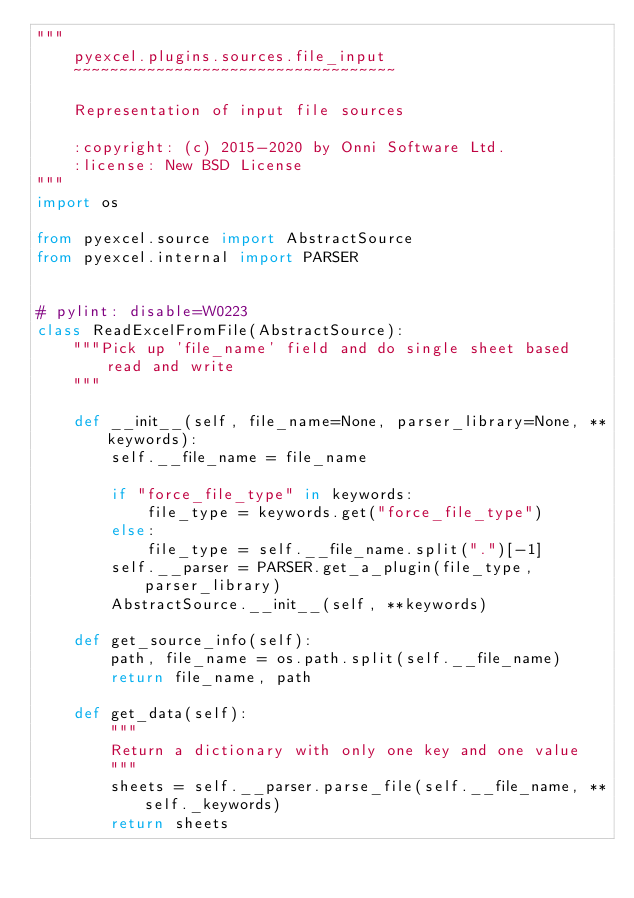Convert code to text. <code><loc_0><loc_0><loc_500><loc_500><_Python_>"""
    pyexcel.plugins.sources.file_input
    ~~~~~~~~~~~~~~~~~~~~~~~~~~~~~~~~~~~

    Representation of input file sources

    :copyright: (c) 2015-2020 by Onni Software Ltd.
    :license: New BSD License
"""
import os

from pyexcel.source import AbstractSource
from pyexcel.internal import PARSER


# pylint: disable=W0223
class ReadExcelFromFile(AbstractSource):
    """Pick up 'file_name' field and do single sheet based read and write
    """

    def __init__(self, file_name=None, parser_library=None, **keywords):
        self.__file_name = file_name

        if "force_file_type" in keywords:
            file_type = keywords.get("force_file_type")
        else:
            file_type = self.__file_name.split(".")[-1]
        self.__parser = PARSER.get_a_plugin(file_type, parser_library)
        AbstractSource.__init__(self, **keywords)

    def get_source_info(self):
        path, file_name = os.path.split(self.__file_name)
        return file_name, path

    def get_data(self):
        """
        Return a dictionary with only one key and one value
        """
        sheets = self.__parser.parse_file(self.__file_name, **self._keywords)
        return sheets
</code> 